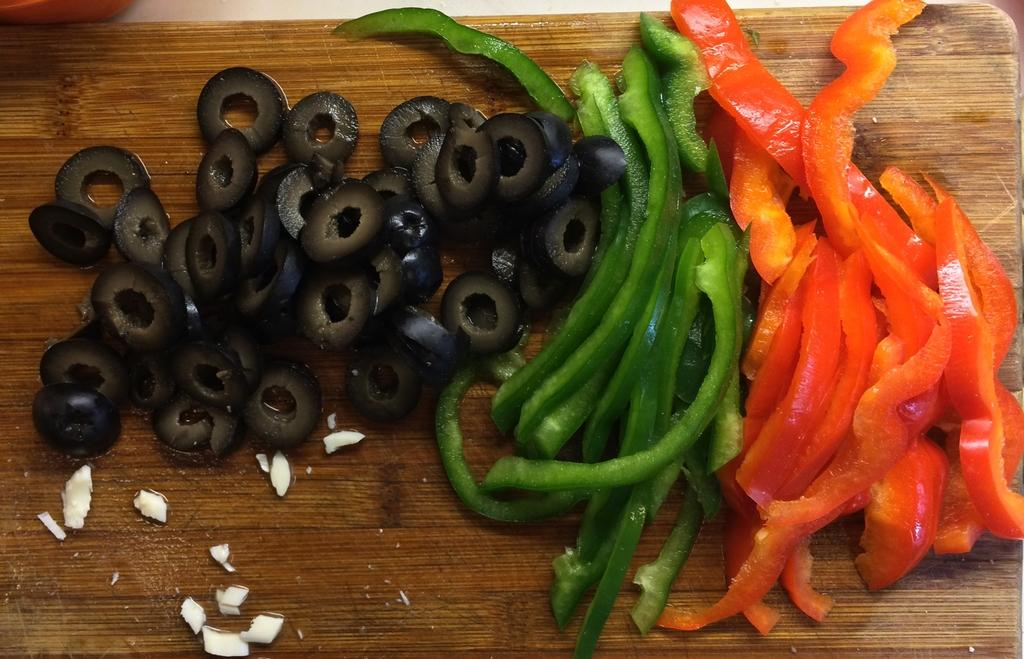What is on the cutting board in the image? There are olives and capsicums on the cutting board in the image. What type of food can be seen on the cutting board? The food items on the cutting board are olives and capsicums. What type of fuel is being used to cook the olives and capsicums in the image? There is no indication of cooking or fuel in the image; it only shows olives and capsicums on a cutting board. 